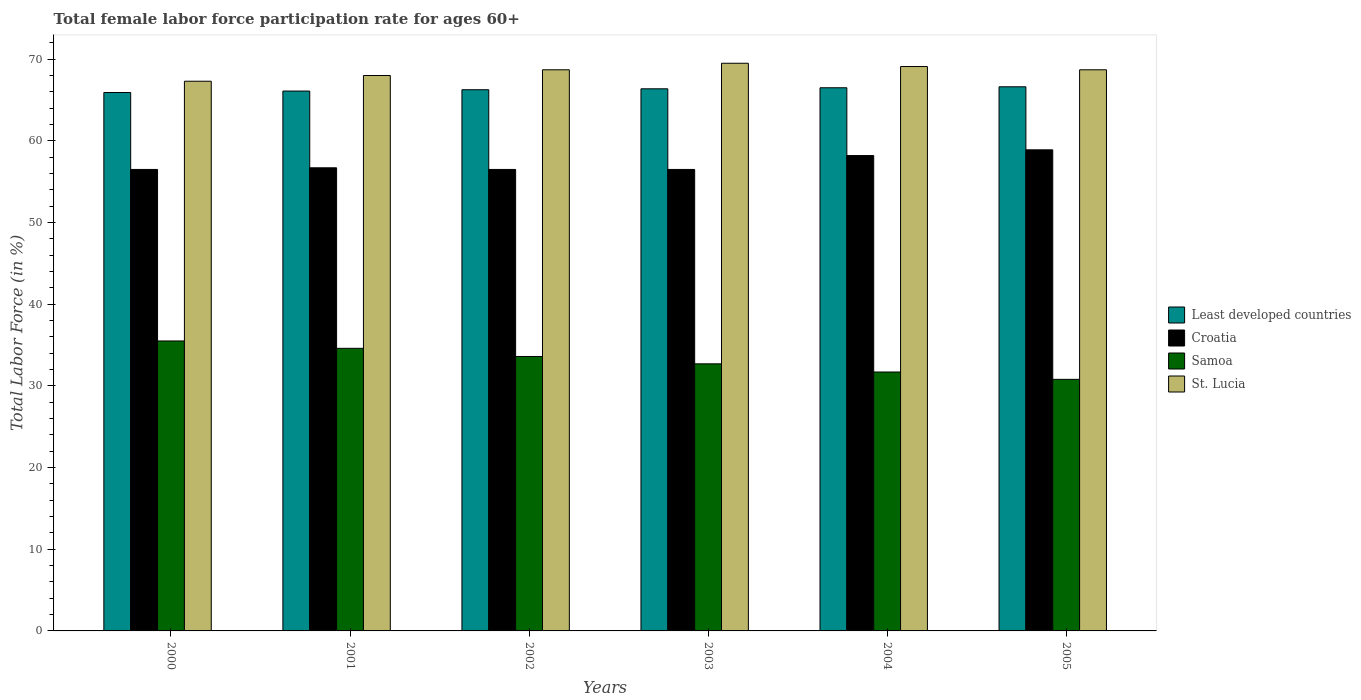How many different coloured bars are there?
Keep it short and to the point. 4. Are the number of bars per tick equal to the number of legend labels?
Keep it short and to the point. Yes. Are the number of bars on each tick of the X-axis equal?
Make the answer very short. Yes. How many bars are there on the 5th tick from the left?
Make the answer very short. 4. What is the label of the 4th group of bars from the left?
Ensure brevity in your answer.  2003. In how many cases, is the number of bars for a given year not equal to the number of legend labels?
Your response must be concise. 0. What is the female labor force participation rate in Croatia in 2004?
Offer a very short reply. 58.2. Across all years, what is the maximum female labor force participation rate in Samoa?
Provide a succinct answer. 35.5. Across all years, what is the minimum female labor force participation rate in Samoa?
Make the answer very short. 30.8. In which year was the female labor force participation rate in Least developed countries minimum?
Keep it short and to the point. 2000. What is the total female labor force participation rate in Croatia in the graph?
Your answer should be compact. 343.3. What is the difference between the female labor force participation rate in Croatia in 2000 and that in 2004?
Keep it short and to the point. -1.7. What is the difference between the female labor force participation rate in Samoa in 2003 and the female labor force participation rate in Croatia in 2002?
Provide a short and direct response. -23.8. What is the average female labor force participation rate in Croatia per year?
Offer a terse response. 57.22. In the year 2001, what is the difference between the female labor force participation rate in St. Lucia and female labor force participation rate in Least developed countries?
Offer a terse response. 1.9. What is the ratio of the female labor force participation rate in St. Lucia in 2002 to that in 2005?
Offer a terse response. 1. Is the difference between the female labor force participation rate in St. Lucia in 2001 and 2005 greater than the difference between the female labor force participation rate in Least developed countries in 2001 and 2005?
Ensure brevity in your answer.  No. What is the difference between the highest and the second highest female labor force participation rate in St. Lucia?
Make the answer very short. 0.4. What is the difference between the highest and the lowest female labor force participation rate in Samoa?
Your answer should be compact. 4.7. Is the sum of the female labor force participation rate in Samoa in 2001 and 2005 greater than the maximum female labor force participation rate in Least developed countries across all years?
Provide a succinct answer. No. What does the 2nd bar from the left in 2004 represents?
Provide a short and direct response. Croatia. What does the 4th bar from the right in 2001 represents?
Provide a short and direct response. Least developed countries. How many bars are there?
Provide a short and direct response. 24. How many years are there in the graph?
Your answer should be very brief. 6. Are the values on the major ticks of Y-axis written in scientific E-notation?
Provide a short and direct response. No. Does the graph contain any zero values?
Make the answer very short. No. Does the graph contain grids?
Your response must be concise. No. Where does the legend appear in the graph?
Your response must be concise. Center right. How are the legend labels stacked?
Ensure brevity in your answer.  Vertical. What is the title of the graph?
Your response must be concise. Total female labor force participation rate for ages 60+. Does "Sub-Saharan Africa (developing only)" appear as one of the legend labels in the graph?
Your answer should be compact. No. What is the label or title of the X-axis?
Provide a succinct answer. Years. What is the Total Labor Force (in %) of Least developed countries in 2000?
Make the answer very short. 65.92. What is the Total Labor Force (in %) of Croatia in 2000?
Offer a terse response. 56.5. What is the Total Labor Force (in %) in Samoa in 2000?
Provide a short and direct response. 35.5. What is the Total Labor Force (in %) of St. Lucia in 2000?
Give a very brief answer. 67.3. What is the Total Labor Force (in %) in Least developed countries in 2001?
Give a very brief answer. 66.1. What is the Total Labor Force (in %) of Croatia in 2001?
Ensure brevity in your answer.  56.7. What is the Total Labor Force (in %) in Samoa in 2001?
Offer a very short reply. 34.6. What is the Total Labor Force (in %) in St. Lucia in 2001?
Offer a very short reply. 68. What is the Total Labor Force (in %) in Least developed countries in 2002?
Your answer should be very brief. 66.26. What is the Total Labor Force (in %) in Croatia in 2002?
Provide a short and direct response. 56.5. What is the Total Labor Force (in %) of Samoa in 2002?
Your response must be concise. 33.6. What is the Total Labor Force (in %) of St. Lucia in 2002?
Your answer should be compact. 68.7. What is the Total Labor Force (in %) in Least developed countries in 2003?
Give a very brief answer. 66.37. What is the Total Labor Force (in %) in Croatia in 2003?
Ensure brevity in your answer.  56.5. What is the Total Labor Force (in %) in Samoa in 2003?
Keep it short and to the point. 32.7. What is the Total Labor Force (in %) in St. Lucia in 2003?
Offer a very short reply. 69.5. What is the Total Labor Force (in %) of Least developed countries in 2004?
Provide a succinct answer. 66.5. What is the Total Labor Force (in %) of Croatia in 2004?
Your answer should be compact. 58.2. What is the Total Labor Force (in %) of Samoa in 2004?
Make the answer very short. 31.7. What is the Total Labor Force (in %) of St. Lucia in 2004?
Ensure brevity in your answer.  69.1. What is the Total Labor Force (in %) in Least developed countries in 2005?
Your answer should be compact. 66.62. What is the Total Labor Force (in %) of Croatia in 2005?
Provide a succinct answer. 58.9. What is the Total Labor Force (in %) of Samoa in 2005?
Your response must be concise. 30.8. What is the Total Labor Force (in %) of St. Lucia in 2005?
Make the answer very short. 68.7. Across all years, what is the maximum Total Labor Force (in %) of Least developed countries?
Your answer should be compact. 66.62. Across all years, what is the maximum Total Labor Force (in %) of Croatia?
Ensure brevity in your answer.  58.9. Across all years, what is the maximum Total Labor Force (in %) of Samoa?
Offer a very short reply. 35.5. Across all years, what is the maximum Total Labor Force (in %) in St. Lucia?
Provide a short and direct response. 69.5. Across all years, what is the minimum Total Labor Force (in %) of Least developed countries?
Provide a succinct answer. 65.92. Across all years, what is the minimum Total Labor Force (in %) in Croatia?
Give a very brief answer. 56.5. Across all years, what is the minimum Total Labor Force (in %) of Samoa?
Your answer should be very brief. 30.8. Across all years, what is the minimum Total Labor Force (in %) of St. Lucia?
Your response must be concise. 67.3. What is the total Total Labor Force (in %) of Least developed countries in the graph?
Your answer should be very brief. 397.77. What is the total Total Labor Force (in %) in Croatia in the graph?
Your response must be concise. 343.3. What is the total Total Labor Force (in %) of Samoa in the graph?
Provide a short and direct response. 198.9. What is the total Total Labor Force (in %) of St. Lucia in the graph?
Keep it short and to the point. 411.3. What is the difference between the Total Labor Force (in %) of Least developed countries in 2000 and that in 2001?
Your response must be concise. -0.18. What is the difference between the Total Labor Force (in %) in St. Lucia in 2000 and that in 2001?
Your answer should be very brief. -0.7. What is the difference between the Total Labor Force (in %) in Least developed countries in 2000 and that in 2002?
Offer a terse response. -0.34. What is the difference between the Total Labor Force (in %) of Croatia in 2000 and that in 2002?
Provide a succinct answer. 0. What is the difference between the Total Labor Force (in %) of St. Lucia in 2000 and that in 2002?
Your response must be concise. -1.4. What is the difference between the Total Labor Force (in %) of Least developed countries in 2000 and that in 2003?
Your answer should be very brief. -0.45. What is the difference between the Total Labor Force (in %) of Least developed countries in 2000 and that in 2004?
Your answer should be very brief. -0.58. What is the difference between the Total Labor Force (in %) of Samoa in 2000 and that in 2004?
Provide a succinct answer. 3.8. What is the difference between the Total Labor Force (in %) in St. Lucia in 2000 and that in 2004?
Your answer should be very brief. -1.8. What is the difference between the Total Labor Force (in %) of Least developed countries in 2000 and that in 2005?
Offer a terse response. -0.7. What is the difference between the Total Labor Force (in %) of Least developed countries in 2001 and that in 2002?
Your answer should be very brief. -0.16. What is the difference between the Total Labor Force (in %) of St. Lucia in 2001 and that in 2002?
Your answer should be compact. -0.7. What is the difference between the Total Labor Force (in %) in Least developed countries in 2001 and that in 2003?
Provide a succinct answer. -0.27. What is the difference between the Total Labor Force (in %) in Samoa in 2001 and that in 2003?
Keep it short and to the point. 1.9. What is the difference between the Total Labor Force (in %) of St. Lucia in 2001 and that in 2003?
Provide a short and direct response. -1.5. What is the difference between the Total Labor Force (in %) of Least developed countries in 2001 and that in 2004?
Make the answer very short. -0.4. What is the difference between the Total Labor Force (in %) of Croatia in 2001 and that in 2004?
Ensure brevity in your answer.  -1.5. What is the difference between the Total Labor Force (in %) of St. Lucia in 2001 and that in 2004?
Keep it short and to the point. -1.1. What is the difference between the Total Labor Force (in %) of Least developed countries in 2001 and that in 2005?
Offer a very short reply. -0.52. What is the difference between the Total Labor Force (in %) of St. Lucia in 2001 and that in 2005?
Give a very brief answer. -0.7. What is the difference between the Total Labor Force (in %) in Least developed countries in 2002 and that in 2003?
Provide a short and direct response. -0.11. What is the difference between the Total Labor Force (in %) in Samoa in 2002 and that in 2003?
Provide a succinct answer. 0.9. What is the difference between the Total Labor Force (in %) in Least developed countries in 2002 and that in 2004?
Offer a very short reply. -0.24. What is the difference between the Total Labor Force (in %) of St. Lucia in 2002 and that in 2004?
Provide a succinct answer. -0.4. What is the difference between the Total Labor Force (in %) in Least developed countries in 2002 and that in 2005?
Your answer should be very brief. -0.36. What is the difference between the Total Labor Force (in %) in Croatia in 2002 and that in 2005?
Your answer should be very brief. -2.4. What is the difference between the Total Labor Force (in %) in Least developed countries in 2003 and that in 2004?
Provide a short and direct response. -0.13. What is the difference between the Total Labor Force (in %) of Croatia in 2003 and that in 2004?
Your answer should be compact. -1.7. What is the difference between the Total Labor Force (in %) of St. Lucia in 2003 and that in 2004?
Offer a terse response. 0.4. What is the difference between the Total Labor Force (in %) in Least developed countries in 2003 and that in 2005?
Ensure brevity in your answer.  -0.25. What is the difference between the Total Labor Force (in %) in Croatia in 2003 and that in 2005?
Keep it short and to the point. -2.4. What is the difference between the Total Labor Force (in %) in Least developed countries in 2004 and that in 2005?
Your answer should be compact. -0.12. What is the difference between the Total Labor Force (in %) in Least developed countries in 2000 and the Total Labor Force (in %) in Croatia in 2001?
Provide a short and direct response. 9.22. What is the difference between the Total Labor Force (in %) in Least developed countries in 2000 and the Total Labor Force (in %) in Samoa in 2001?
Offer a terse response. 31.32. What is the difference between the Total Labor Force (in %) in Least developed countries in 2000 and the Total Labor Force (in %) in St. Lucia in 2001?
Offer a terse response. -2.08. What is the difference between the Total Labor Force (in %) of Croatia in 2000 and the Total Labor Force (in %) of Samoa in 2001?
Your answer should be compact. 21.9. What is the difference between the Total Labor Force (in %) in Samoa in 2000 and the Total Labor Force (in %) in St. Lucia in 2001?
Give a very brief answer. -32.5. What is the difference between the Total Labor Force (in %) in Least developed countries in 2000 and the Total Labor Force (in %) in Croatia in 2002?
Make the answer very short. 9.42. What is the difference between the Total Labor Force (in %) in Least developed countries in 2000 and the Total Labor Force (in %) in Samoa in 2002?
Keep it short and to the point. 32.32. What is the difference between the Total Labor Force (in %) in Least developed countries in 2000 and the Total Labor Force (in %) in St. Lucia in 2002?
Make the answer very short. -2.78. What is the difference between the Total Labor Force (in %) of Croatia in 2000 and the Total Labor Force (in %) of Samoa in 2002?
Ensure brevity in your answer.  22.9. What is the difference between the Total Labor Force (in %) of Samoa in 2000 and the Total Labor Force (in %) of St. Lucia in 2002?
Offer a very short reply. -33.2. What is the difference between the Total Labor Force (in %) in Least developed countries in 2000 and the Total Labor Force (in %) in Croatia in 2003?
Provide a succinct answer. 9.42. What is the difference between the Total Labor Force (in %) of Least developed countries in 2000 and the Total Labor Force (in %) of Samoa in 2003?
Your answer should be compact. 33.22. What is the difference between the Total Labor Force (in %) of Least developed countries in 2000 and the Total Labor Force (in %) of St. Lucia in 2003?
Your answer should be compact. -3.58. What is the difference between the Total Labor Force (in %) of Croatia in 2000 and the Total Labor Force (in %) of Samoa in 2003?
Give a very brief answer. 23.8. What is the difference between the Total Labor Force (in %) in Samoa in 2000 and the Total Labor Force (in %) in St. Lucia in 2003?
Keep it short and to the point. -34. What is the difference between the Total Labor Force (in %) in Least developed countries in 2000 and the Total Labor Force (in %) in Croatia in 2004?
Keep it short and to the point. 7.72. What is the difference between the Total Labor Force (in %) in Least developed countries in 2000 and the Total Labor Force (in %) in Samoa in 2004?
Give a very brief answer. 34.22. What is the difference between the Total Labor Force (in %) of Least developed countries in 2000 and the Total Labor Force (in %) of St. Lucia in 2004?
Ensure brevity in your answer.  -3.18. What is the difference between the Total Labor Force (in %) of Croatia in 2000 and the Total Labor Force (in %) of Samoa in 2004?
Keep it short and to the point. 24.8. What is the difference between the Total Labor Force (in %) of Croatia in 2000 and the Total Labor Force (in %) of St. Lucia in 2004?
Make the answer very short. -12.6. What is the difference between the Total Labor Force (in %) in Samoa in 2000 and the Total Labor Force (in %) in St. Lucia in 2004?
Make the answer very short. -33.6. What is the difference between the Total Labor Force (in %) of Least developed countries in 2000 and the Total Labor Force (in %) of Croatia in 2005?
Your answer should be compact. 7.02. What is the difference between the Total Labor Force (in %) in Least developed countries in 2000 and the Total Labor Force (in %) in Samoa in 2005?
Keep it short and to the point. 35.12. What is the difference between the Total Labor Force (in %) in Least developed countries in 2000 and the Total Labor Force (in %) in St. Lucia in 2005?
Ensure brevity in your answer.  -2.78. What is the difference between the Total Labor Force (in %) in Croatia in 2000 and the Total Labor Force (in %) in Samoa in 2005?
Your answer should be compact. 25.7. What is the difference between the Total Labor Force (in %) in Samoa in 2000 and the Total Labor Force (in %) in St. Lucia in 2005?
Keep it short and to the point. -33.2. What is the difference between the Total Labor Force (in %) of Least developed countries in 2001 and the Total Labor Force (in %) of Croatia in 2002?
Give a very brief answer. 9.6. What is the difference between the Total Labor Force (in %) of Least developed countries in 2001 and the Total Labor Force (in %) of Samoa in 2002?
Your answer should be compact. 32.5. What is the difference between the Total Labor Force (in %) in Least developed countries in 2001 and the Total Labor Force (in %) in St. Lucia in 2002?
Offer a very short reply. -2.6. What is the difference between the Total Labor Force (in %) in Croatia in 2001 and the Total Labor Force (in %) in Samoa in 2002?
Ensure brevity in your answer.  23.1. What is the difference between the Total Labor Force (in %) in Croatia in 2001 and the Total Labor Force (in %) in St. Lucia in 2002?
Give a very brief answer. -12. What is the difference between the Total Labor Force (in %) in Samoa in 2001 and the Total Labor Force (in %) in St. Lucia in 2002?
Ensure brevity in your answer.  -34.1. What is the difference between the Total Labor Force (in %) of Least developed countries in 2001 and the Total Labor Force (in %) of Croatia in 2003?
Give a very brief answer. 9.6. What is the difference between the Total Labor Force (in %) of Least developed countries in 2001 and the Total Labor Force (in %) of Samoa in 2003?
Keep it short and to the point. 33.4. What is the difference between the Total Labor Force (in %) of Least developed countries in 2001 and the Total Labor Force (in %) of St. Lucia in 2003?
Your answer should be very brief. -3.4. What is the difference between the Total Labor Force (in %) of Samoa in 2001 and the Total Labor Force (in %) of St. Lucia in 2003?
Make the answer very short. -34.9. What is the difference between the Total Labor Force (in %) of Least developed countries in 2001 and the Total Labor Force (in %) of Croatia in 2004?
Keep it short and to the point. 7.9. What is the difference between the Total Labor Force (in %) in Least developed countries in 2001 and the Total Labor Force (in %) in Samoa in 2004?
Provide a succinct answer. 34.4. What is the difference between the Total Labor Force (in %) of Least developed countries in 2001 and the Total Labor Force (in %) of St. Lucia in 2004?
Provide a succinct answer. -3. What is the difference between the Total Labor Force (in %) in Samoa in 2001 and the Total Labor Force (in %) in St. Lucia in 2004?
Offer a terse response. -34.5. What is the difference between the Total Labor Force (in %) of Least developed countries in 2001 and the Total Labor Force (in %) of Croatia in 2005?
Make the answer very short. 7.2. What is the difference between the Total Labor Force (in %) in Least developed countries in 2001 and the Total Labor Force (in %) in Samoa in 2005?
Make the answer very short. 35.3. What is the difference between the Total Labor Force (in %) in Least developed countries in 2001 and the Total Labor Force (in %) in St. Lucia in 2005?
Your response must be concise. -2.6. What is the difference between the Total Labor Force (in %) in Croatia in 2001 and the Total Labor Force (in %) in Samoa in 2005?
Keep it short and to the point. 25.9. What is the difference between the Total Labor Force (in %) of Croatia in 2001 and the Total Labor Force (in %) of St. Lucia in 2005?
Your answer should be compact. -12. What is the difference between the Total Labor Force (in %) in Samoa in 2001 and the Total Labor Force (in %) in St. Lucia in 2005?
Offer a very short reply. -34.1. What is the difference between the Total Labor Force (in %) of Least developed countries in 2002 and the Total Labor Force (in %) of Croatia in 2003?
Your response must be concise. 9.76. What is the difference between the Total Labor Force (in %) of Least developed countries in 2002 and the Total Labor Force (in %) of Samoa in 2003?
Provide a succinct answer. 33.56. What is the difference between the Total Labor Force (in %) of Least developed countries in 2002 and the Total Labor Force (in %) of St. Lucia in 2003?
Offer a very short reply. -3.24. What is the difference between the Total Labor Force (in %) of Croatia in 2002 and the Total Labor Force (in %) of Samoa in 2003?
Your response must be concise. 23.8. What is the difference between the Total Labor Force (in %) of Samoa in 2002 and the Total Labor Force (in %) of St. Lucia in 2003?
Your response must be concise. -35.9. What is the difference between the Total Labor Force (in %) of Least developed countries in 2002 and the Total Labor Force (in %) of Croatia in 2004?
Give a very brief answer. 8.06. What is the difference between the Total Labor Force (in %) of Least developed countries in 2002 and the Total Labor Force (in %) of Samoa in 2004?
Offer a very short reply. 34.56. What is the difference between the Total Labor Force (in %) in Least developed countries in 2002 and the Total Labor Force (in %) in St. Lucia in 2004?
Offer a very short reply. -2.84. What is the difference between the Total Labor Force (in %) in Croatia in 2002 and the Total Labor Force (in %) in Samoa in 2004?
Your answer should be very brief. 24.8. What is the difference between the Total Labor Force (in %) of Samoa in 2002 and the Total Labor Force (in %) of St. Lucia in 2004?
Offer a terse response. -35.5. What is the difference between the Total Labor Force (in %) of Least developed countries in 2002 and the Total Labor Force (in %) of Croatia in 2005?
Your answer should be very brief. 7.36. What is the difference between the Total Labor Force (in %) in Least developed countries in 2002 and the Total Labor Force (in %) in Samoa in 2005?
Keep it short and to the point. 35.46. What is the difference between the Total Labor Force (in %) in Least developed countries in 2002 and the Total Labor Force (in %) in St. Lucia in 2005?
Give a very brief answer. -2.44. What is the difference between the Total Labor Force (in %) in Croatia in 2002 and the Total Labor Force (in %) in Samoa in 2005?
Offer a very short reply. 25.7. What is the difference between the Total Labor Force (in %) in Samoa in 2002 and the Total Labor Force (in %) in St. Lucia in 2005?
Offer a very short reply. -35.1. What is the difference between the Total Labor Force (in %) of Least developed countries in 2003 and the Total Labor Force (in %) of Croatia in 2004?
Provide a succinct answer. 8.17. What is the difference between the Total Labor Force (in %) in Least developed countries in 2003 and the Total Labor Force (in %) in Samoa in 2004?
Provide a short and direct response. 34.67. What is the difference between the Total Labor Force (in %) of Least developed countries in 2003 and the Total Labor Force (in %) of St. Lucia in 2004?
Your answer should be compact. -2.73. What is the difference between the Total Labor Force (in %) in Croatia in 2003 and the Total Labor Force (in %) in Samoa in 2004?
Make the answer very short. 24.8. What is the difference between the Total Labor Force (in %) in Croatia in 2003 and the Total Labor Force (in %) in St. Lucia in 2004?
Give a very brief answer. -12.6. What is the difference between the Total Labor Force (in %) in Samoa in 2003 and the Total Labor Force (in %) in St. Lucia in 2004?
Keep it short and to the point. -36.4. What is the difference between the Total Labor Force (in %) in Least developed countries in 2003 and the Total Labor Force (in %) in Croatia in 2005?
Make the answer very short. 7.47. What is the difference between the Total Labor Force (in %) in Least developed countries in 2003 and the Total Labor Force (in %) in Samoa in 2005?
Offer a terse response. 35.57. What is the difference between the Total Labor Force (in %) of Least developed countries in 2003 and the Total Labor Force (in %) of St. Lucia in 2005?
Give a very brief answer. -2.33. What is the difference between the Total Labor Force (in %) in Croatia in 2003 and the Total Labor Force (in %) in Samoa in 2005?
Your answer should be compact. 25.7. What is the difference between the Total Labor Force (in %) in Croatia in 2003 and the Total Labor Force (in %) in St. Lucia in 2005?
Make the answer very short. -12.2. What is the difference between the Total Labor Force (in %) of Samoa in 2003 and the Total Labor Force (in %) of St. Lucia in 2005?
Give a very brief answer. -36. What is the difference between the Total Labor Force (in %) of Least developed countries in 2004 and the Total Labor Force (in %) of Croatia in 2005?
Offer a very short reply. 7.6. What is the difference between the Total Labor Force (in %) of Least developed countries in 2004 and the Total Labor Force (in %) of Samoa in 2005?
Offer a very short reply. 35.7. What is the difference between the Total Labor Force (in %) in Least developed countries in 2004 and the Total Labor Force (in %) in St. Lucia in 2005?
Your answer should be very brief. -2.2. What is the difference between the Total Labor Force (in %) in Croatia in 2004 and the Total Labor Force (in %) in Samoa in 2005?
Your answer should be very brief. 27.4. What is the difference between the Total Labor Force (in %) in Samoa in 2004 and the Total Labor Force (in %) in St. Lucia in 2005?
Offer a terse response. -37. What is the average Total Labor Force (in %) of Least developed countries per year?
Ensure brevity in your answer.  66.29. What is the average Total Labor Force (in %) in Croatia per year?
Provide a short and direct response. 57.22. What is the average Total Labor Force (in %) of Samoa per year?
Offer a terse response. 33.15. What is the average Total Labor Force (in %) of St. Lucia per year?
Your response must be concise. 68.55. In the year 2000, what is the difference between the Total Labor Force (in %) in Least developed countries and Total Labor Force (in %) in Croatia?
Your answer should be very brief. 9.42. In the year 2000, what is the difference between the Total Labor Force (in %) in Least developed countries and Total Labor Force (in %) in Samoa?
Provide a short and direct response. 30.42. In the year 2000, what is the difference between the Total Labor Force (in %) of Least developed countries and Total Labor Force (in %) of St. Lucia?
Ensure brevity in your answer.  -1.38. In the year 2000, what is the difference between the Total Labor Force (in %) of Croatia and Total Labor Force (in %) of St. Lucia?
Provide a short and direct response. -10.8. In the year 2000, what is the difference between the Total Labor Force (in %) of Samoa and Total Labor Force (in %) of St. Lucia?
Your answer should be compact. -31.8. In the year 2001, what is the difference between the Total Labor Force (in %) in Least developed countries and Total Labor Force (in %) in Croatia?
Keep it short and to the point. 9.4. In the year 2001, what is the difference between the Total Labor Force (in %) in Least developed countries and Total Labor Force (in %) in Samoa?
Provide a succinct answer. 31.5. In the year 2001, what is the difference between the Total Labor Force (in %) in Least developed countries and Total Labor Force (in %) in St. Lucia?
Your answer should be very brief. -1.9. In the year 2001, what is the difference between the Total Labor Force (in %) in Croatia and Total Labor Force (in %) in Samoa?
Keep it short and to the point. 22.1. In the year 2001, what is the difference between the Total Labor Force (in %) of Samoa and Total Labor Force (in %) of St. Lucia?
Offer a terse response. -33.4. In the year 2002, what is the difference between the Total Labor Force (in %) in Least developed countries and Total Labor Force (in %) in Croatia?
Provide a short and direct response. 9.76. In the year 2002, what is the difference between the Total Labor Force (in %) in Least developed countries and Total Labor Force (in %) in Samoa?
Give a very brief answer. 32.66. In the year 2002, what is the difference between the Total Labor Force (in %) in Least developed countries and Total Labor Force (in %) in St. Lucia?
Give a very brief answer. -2.44. In the year 2002, what is the difference between the Total Labor Force (in %) of Croatia and Total Labor Force (in %) of Samoa?
Your answer should be very brief. 22.9. In the year 2002, what is the difference between the Total Labor Force (in %) in Croatia and Total Labor Force (in %) in St. Lucia?
Make the answer very short. -12.2. In the year 2002, what is the difference between the Total Labor Force (in %) of Samoa and Total Labor Force (in %) of St. Lucia?
Make the answer very short. -35.1. In the year 2003, what is the difference between the Total Labor Force (in %) of Least developed countries and Total Labor Force (in %) of Croatia?
Your response must be concise. 9.87. In the year 2003, what is the difference between the Total Labor Force (in %) in Least developed countries and Total Labor Force (in %) in Samoa?
Keep it short and to the point. 33.67. In the year 2003, what is the difference between the Total Labor Force (in %) in Least developed countries and Total Labor Force (in %) in St. Lucia?
Offer a terse response. -3.13. In the year 2003, what is the difference between the Total Labor Force (in %) of Croatia and Total Labor Force (in %) of Samoa?
Offer a terse response. 23.8. In the year 2003, what is the difference between the Total Labor Force (in %) of Croatia and Total Labor Force (in %) of St. Lucia?
Ensure brevity in your answer.  -13. In the year 2003, what is the difference between the Total Labor Force (in %) of Samoa and Total Labor Force (in %) of St. Lucia?
Your answer should be very brief. -36.8. In the year 2004, what is the difference between the Total Labor Force (in %) in Least developed countries and Total Labor Force (in %) in Croatia?
Keep it short and to the point. 8.3. In the year 2004, what is the difference between the Total Labor Force (in %) of Least developed countries and Total Labor Force (in %) of Samoa?
Provide a short and direct response. 34.8. In the year 2004, what is the difference between the Total Labor Force (in %) in Least developed countries and Total Labor Force (in %) in St. Lucia?
Keep it short and to the point. -2.6. In the year 2004, what is the difference between the Total Labor Force (in %) in Croatia and Total Labor Force (in %) in St. Lucia?
Provide a succinct answer. -10.9. In the year 2004, what is the difference between the Total Labor Force (in %) of Samoa and Total Labor Force (in %) of St. Lucia?
Give a very brief answer. -37.4. In the year 2005, what is the difference between the Total Labor Force (in %) in Least developed countries and Total Labor Force (in %) in Croatia?
Provide a succinct answer. 7.72. In the year 2005, what is the difference between the Total Labor Force (in %) in Least developed countries and Total Labor Force (in %) in Samoa?
Offer a very short reply. 35.82. In the year 2005, what is the difference between the Total Labor Force (in %) in Least developed countries and Total Labor Force (in %) in St. Lucia?
Give a very brief answer. -2.08. In the year 2005, what is the difference between the Total Labor Force (in %) of Croatia and Total Labor Force (in %) of Samoa?
Ensure brevity in your answer.  28.1. In the year 2005, what is the difference between the Total Labor Force (in %) of Samoa and Total Labor Force (in %) of St. Lucia?
Your response must be concise. -37.9. What is the ratio of the Total Labor Force (in %) of Least developed countries in 2000 to that in 2001?
Your response must be concise. 1. What is the ratio of the Total Labor Force (in %) in Croatia in 2000 to that in 2001?
Your response must be concise. 1. What is the ratio of the Total Labor Force (in %) in Samoa in 2000 to that in 2001?
Your response must be concise. 1.03. What is the ratio of the Total Labor Force (in %) of Least developed countries in 2000 to that in 2002?
Keep it short and to the point. 0.99. What is the ratio of the Total Labor Force (in %) in Samoa in 2000 to that in 2002?
Ensure brevity in your answer.  1.06. What is the ratio of the Total Labor Force (in %) in St. Lucia in 2000 to that in 2002?
Give a very brief answer. 0.98. What is the ratio of the Total Labor Force (in %) in Samoa in 2000 to that in 2003?
Make the answer very short. 1.09. What is the ratio of the Total Labor Force (in %) in St. Lucia in 2000 to that in 2003?
Keep it short and to the point. 0.97. What is the ratio of the Total Labor Force (in %) of Least developed countries in 2000 to that in 2004?
Offer a terse response. 0.99. What is the ratio of the Total Labor Force (in %) of Croatia in 2000 to that in 2004?
Keep it short and to the point. 0.97. What is the ratio of the Total Labor Force (in %) in Samoa in 2000 to that in 2004?
Give a very brief answer. 1.12. What is the ratio of the Total Labor Force (in %) in Least developed countries in 2000 to that in 2005?
Your response must be concise. 0.99. What is the ratio of the Total Labor Force (in %) of Croatia in 2000 to that in 2005?
Your answer should be compact. 0.96. What is the ratio of the Total Labor Force (in %) in Samoa in 2000 to that in 2005?
Give a very brief answer. 1.15. What is the ratio of the Total Labor Force (in %) of St. Lucia in 2000 to that in 2005?
Keep it short and to the point. 0.98. What is the ratio of the Total Labor Force (in %) in Samoa in 2001 to that in 2002?
Make the answer very short. 1.03. What is the ratio of the Total Labor Force (in %) in Samoa in 2001 to that in 2003?
Ensure brevity in your answer.  1.06. What is the ratio of the Total Labor Force (in %) of St. Lucia in 2001 to that in 2003?
Offer a terse response. 0.98. What is the ratio of the Total Labor Force (in %) of Croatia in 2001 to that in 2004?
Offer a terse response. 0.97. What is the ratio of the Total Labor Force (in %) in Samoa in 2001 to that in 2004?
Your response must be concise. 1.09. What is the ratio of the Total Labor Force (in %) in St. Lucia in 2001 to that in 2004?
Keep it short and to the point. 0.98. What is the ratio of the Total Labor Force (in %) of Croatia in 2001 to that in 2005?
Give a very brief answer. 0.96. What is the ratio of the Total Labor Force (in %) in Samoa in 2001 to that in 2005?
Provide a succinct answer. 1.12. What is the ratio of the Total Labor Force (in %) of Least developed countries in 2002 to that in 2003?
Your answer should be compact. 1. What is the ratio of the Total Labor Force (in %) in Samoa in 2002 to that in 2003?
Provide a short and direct response. 1.03. What is the ratio of the Total Labor Force (in %) of Least developed countries in 2002 to that in 2004?
Your answer should be very brief. 1. What is the ratio of the Total Labor Force (in %) of Croatia in 2002 to that in 2004?
Your answer should be compact. 0.97. What is the ratio of the Total Labor Force (in %) in Samoa in 2002 to that in 2004?
Offer a terse response. 1.06. What is the ratio of the Total Labor Force (in %) in Least developed countries in 2002 to that in 2005?
Your answer should be very brief. 0.99. What is the ratio of the Total Labor Force (in %) in Croatia in 2002 to that in 2005?
Offer a very short reply. 0.96. What is the ratio of the Total Labor Force (in %) of St. Lucia in 2002 to that in 2005?
Your response must be concise. 1. What is the ratio of the Total Labor Force (in %) in Least developed countries in 2003 to that in 2004?
Ensure brevity in your answer.  1. What is the ratio of the Total Labor Force (in %) in Croatia in 2003 to that in 2004?
Your answer should be compact. 0.97. What is the ratio of the Total Labor Force (in %) of Samoa in 2003 to that in 2004?
Offer a terse response. 1.03. What is the ratio of the Total Labor Force (in %) in St. Lucia in 2003 to that in 2004?
Make the answer very short. 1.01. What is the ratio of the Total Labor Force (in %) of Least developed countries in 2003 to that in 2005?
Offer a very short reply. 1. What is the ratio of the Total Labor Force (in %) in Croatia in 2003 to that in 2005?
Provide a short and direct response. 0.96. What is the ratio of the Total Labor Force (in %) of Samoa in 2003 to that in 2005?
Make the answer very short. 1.06. What is the ratio of the Total Labor Force (in %) in St. Lucia in 2003 to that in 2005?
Keep it short and to the point. 1.01. What is the ratio of the Total Labor Force (in %) in Croatia in 2004 to that in 2005?
Provide a short and direct response. 0.99. What is the ratio of the Total Labor Force (in %) of Samoa in 2004 to that in 2005?
Provide a short and direct response. 1.03. What is the ratio of the Total Labor Force (in %) of St. Lucia in 2004 to that in 2005?
Your answer should be very brief. 1.01. What is the difference between the highest and the second highest Total Labor Force (in %) of Least developed countries?
Ensure brevity in your answer.  0.12. What is the difference between the highest and the second highest Total Labor Force (in %) of Samoa?
Your response must be concise. 0.9. What is the difference between the highest and the lowest Total Labor Force (in %) of Least developed countries?
Make the answer very short. 0.7. What is the difference between the highest and the lowest Total Labor Force (in %) in Samoa?
Your answer should be compact. 4.7. 